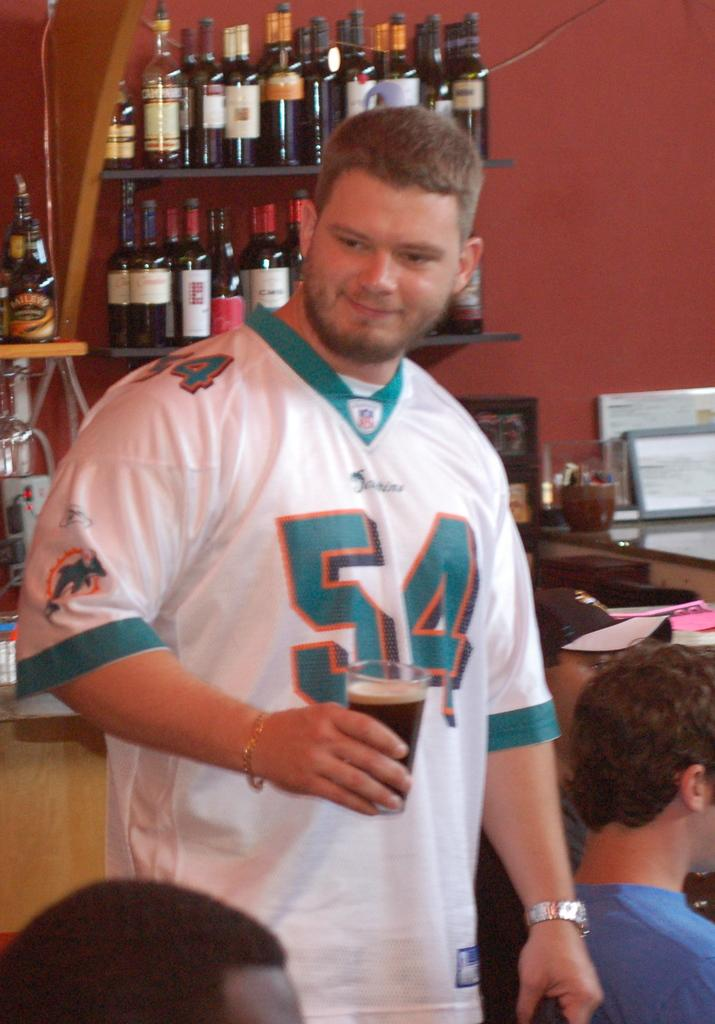<image>
Share a concise interpretation of the image provided. man wearing 54 miami dolphins jersey holding a drink and shelves of alcohol behind him 